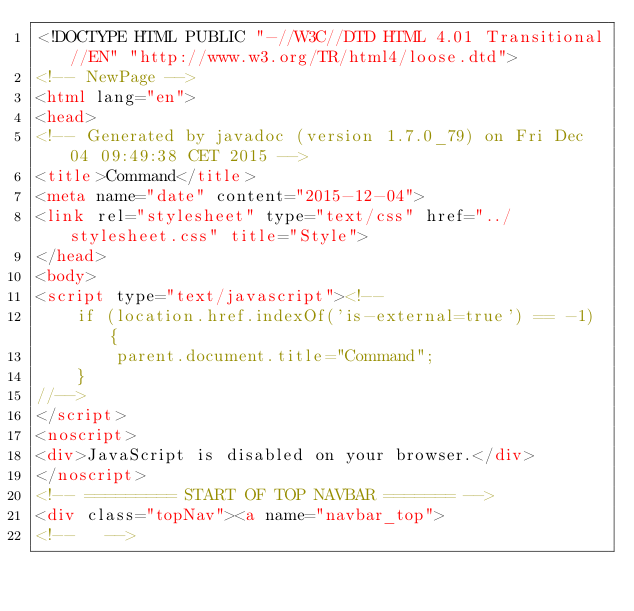Convert code to text. <code><loc_0><loc_0><loc_500><loc_500><_HTML_><!DOCTYPE HTML PUBLIC "-//W3C//DTD HTML 4.01 Transitional//EN" "http://www.w3.org/TR/html4/loose.dtd">
<!-- NewPage -->
<html lang="en">
<head>
<!-- Generated by javadoc (version 1.7.0_79) on Fri Dec 04 09:49:38 CET 2015 -->
<title>Command</title>
<meta name="date" content="2015-12-04">
<link rel="stylesheet" type="text/css" href="../stylesheet.css" title="Style">
</head>
<body>
<script type="text/javascript"><!--
    if (location.href.indexOf('is-external=true') == -1) {
        parent.document.title="Command";
    }
//-->
</script>
<noscript>
<div>JavaScript is disabled on your browser.</div>
</noscript>
<!-- ========= START OF TOP NAVBAR ======= -->
<div class="topNav"><a name="navbar_top">
<!--   --></code> 